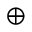Convert formula to latex. <formula><loc_0><loc_0><loc_500><loc_500>\oplus</formula> 